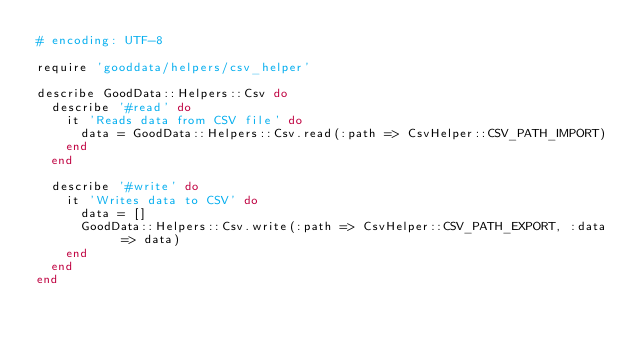Convert code to text. <code><loc_0><loc_0><loc_500><loc_500><_Ruby_># encoding: UTF-8

require 'gooddata/helpers/csv_helper'

describe GoodData::Helpers::Csv do
  describe '#read' do
    it 'Reads data from CSV file' do
      data = GoodData::Helpers::Csv.read(:path => CsvHelper::CSV_PATH_IMPORT)
    end
  end

  describe '#write' do
    it 'Writes data to CSV' do
      data = []
      GoodData::Helpers::Csv.write(:path => CsvHelper::CSV_PATH_EXPORT, :data => data)
    end
  end
end</code> 